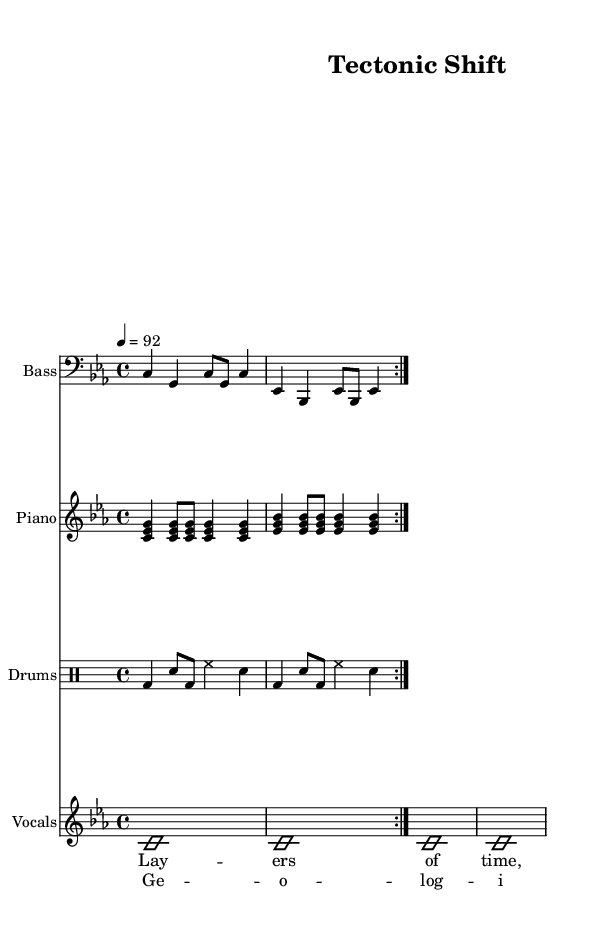What is the key signature of this music? The key signature is C minor, which has three flats (B♭, E♭, and A♭) indicated at the beginning of the staff.
Answer: C minor What is the time signature of this music? The time signature is 4/4, which is shown at the start of the score and means there are four beats in each measure.
Answer: 4/4 What is the tempo marking of this piece? The tempo marking states "4 = 92", indicating a quarter note equals 92 beats per minute, which determines the speed of the performance.
Answer: 92 How many measures are in the bass part? The bass part features two repeated sections with two measures each, resulting in a total of four measures.
Answer: 4 What is the overall theme of the lyrics? The lyrics focus on geological events and their impact on human civilization, highlighting the need to preserve historical records related to these events.
Answer: Geological events How many instruments are featured in this score? The score features four distinct parts: Bass, Piano, Drums, and Vocals, which together create a full arrangement typical of hip hop music.
Answer: 4 What unique characteristic does the drum part have? The drum part is written in a specialized drum notation (drummode), indicating the specific patterns for each instrument like bass drum, snare, and hi-hat.
Answer: Drummode 